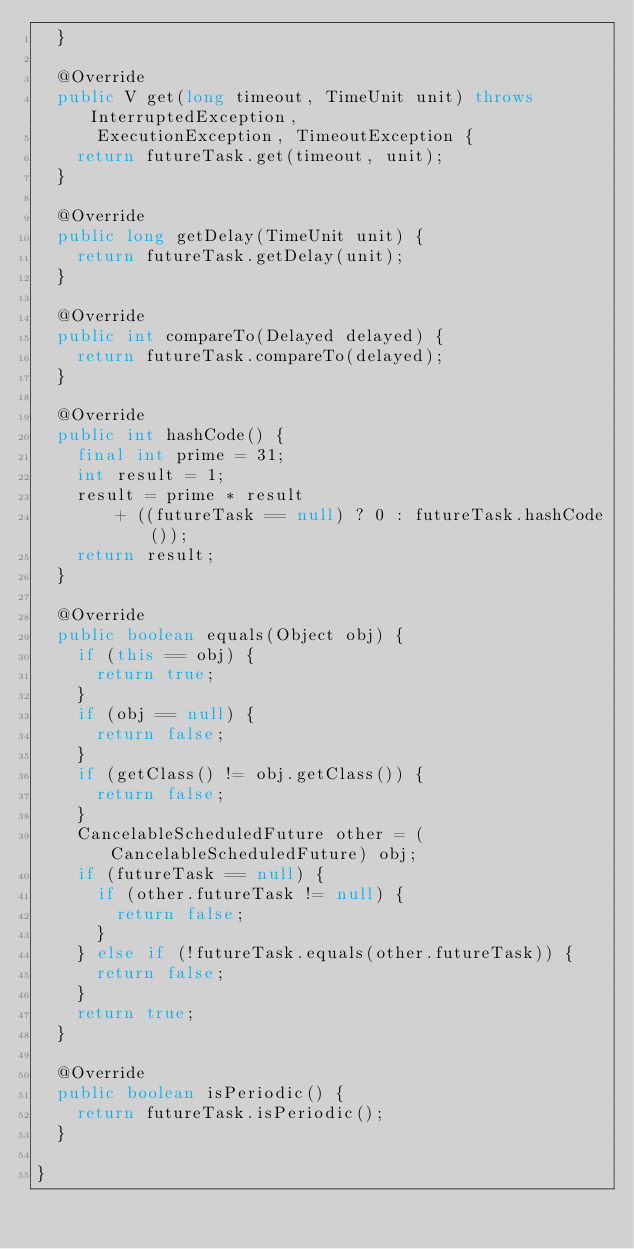Convert code to text. <code><loc_0><loc_0><loc_500><loc_500><_Java_>  }

  @Override
  public V get(long timeout, TimeUnit unit) throws InterruptedException,
      ExecutionException, TimeoutException {
    return futureTask.get(timeout, unit);
  }

  @Override
  public long getDelay(TimeUnit unit) {
    return futureTask.getDelay(unit);
  }

  @Override
  public int compareTo(Delayed delayed) {
    return futureTask.compareTo(delayed);
  }

  @Override
  public int hashCode() {
    final int prime = 31;
    int result = 1;
    result = prime * result
        + ((futureTask == null) ? 0 : futureTask.hashCode());
    return result;
  }

  @Override
  public boolean equals(Object obj) {
    if (this == obj) {
      return true;
    }
    if (obj == null) {
      return false;
    }
    if (getClass() != obj.getClass()) {
      return false;
    }
    CancelableScheduledFuture other = (CancelableScheduledFuture) obj;
    if (futureTask == null) {
      if (other.futureTask != null) {
        return false;
      }
    } else if (!futureTask.equals(other.futureTask)) {
      return false;
    }
    return true;
  }

  @Override
  public boolean isPeriodic() {
    return futureTask.isPeriodic();
  }

}
</code> 